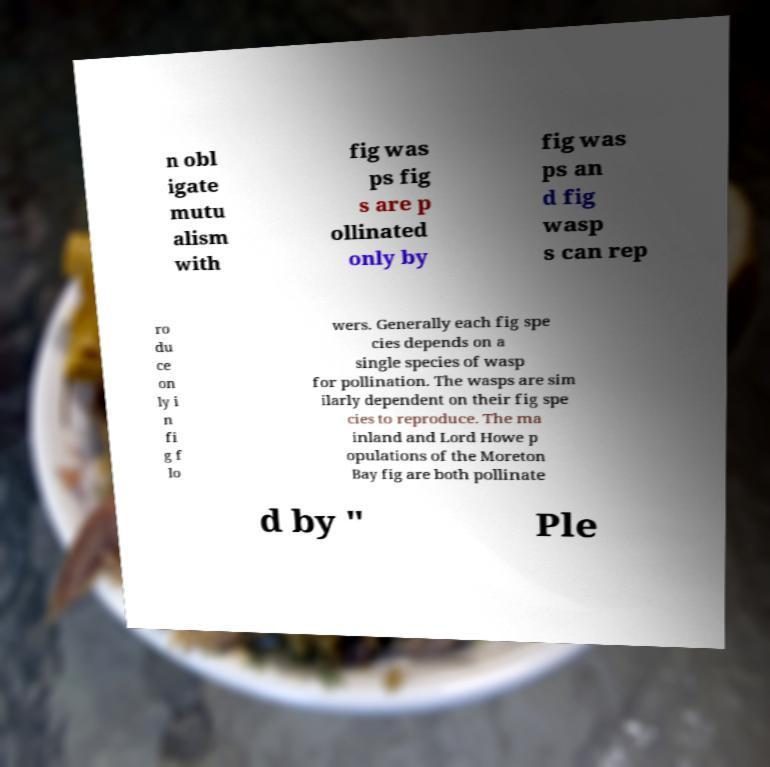I need the written content from this picture converted into text. Can you do that? n obl igate mutu alism with fig was ps fig s are p ollinated only by fig was ps an d fig wasp s can rep ro du ce on ly i n fi g f lo wers. Generally each fig spe cies depends on a single species of wasp for pollination. The wasps are sim ilarly dependent on their fig spe cies to reproduce. The ma inland and Lord Howe p opulations of the Moreton Bay fig are both pollinate d by " Ple 